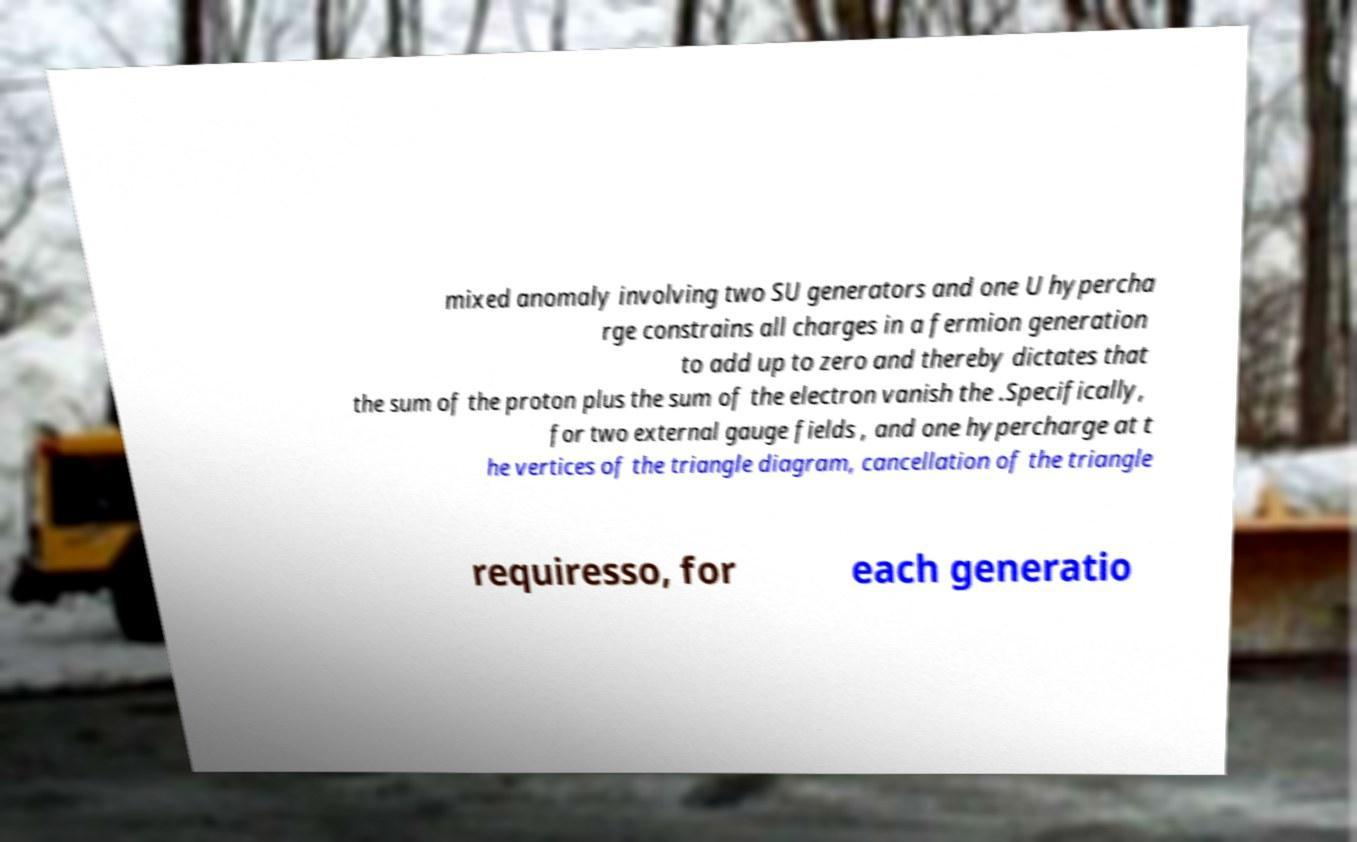Could you extract and type out the text from this image? mixed anomaly involving two SU generators and one U hypercha rge constrains all charges in a fermion generation to add up to zero and thereby dictates that the sum of the proton plus the sum of the electron vanish the .Specifically, for two external gauge fields , and one hypercharge at t he vertices of the triangle diagram, cancellation of the triangle requiresso, for each generatio 